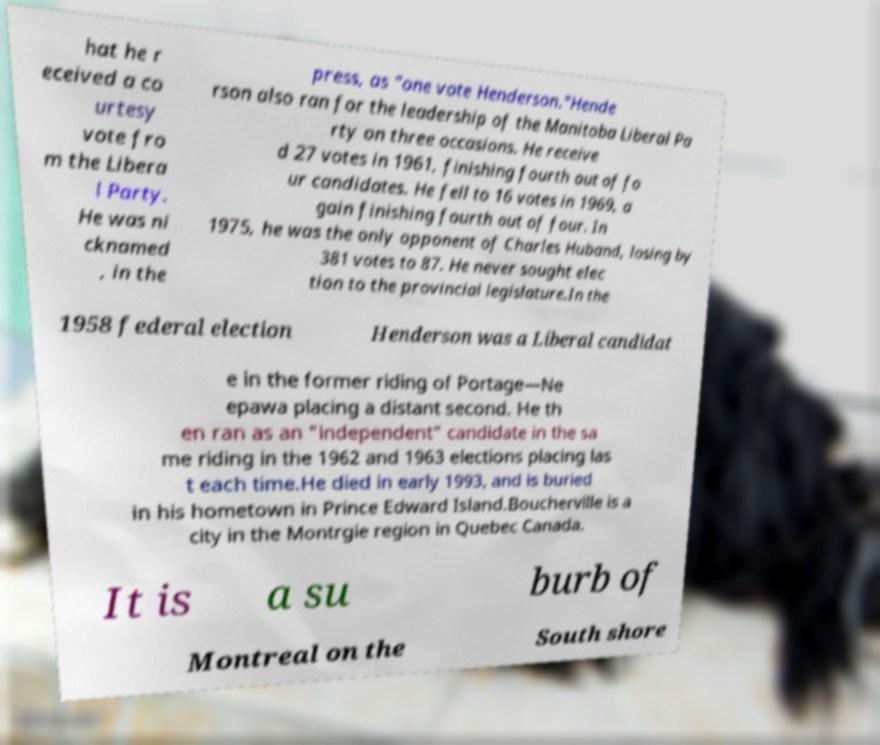What messages or text are displayed in this image? I need them in a readable, typed format. hat he r eceived a co urtesy vote fro m the Libera l Party. He was ni cknamed , in the press, as "one vote Henderson."Hende rson also ran for the leadership of the Manitoba Liberal Pa rty on three occasions. He receive d 27 votes in 1961, finishing fourth out of fo ur candidates. He fell to 16 votes in 1969, a gain finishing fourth out of four. In 1975, he was the only opponent of Charles Huband, losing by 381 votes to 87. He never sought elec tion to the provincial legislature.In the 1958 federal election Henderson was a Liberal candidat e in the former riding of Portage—Ne epawa placing a distant second. He th en ran as an "independent" candidate in the sa me riding in the 1962 and 1963 elections placing las t each time.He died in early 1993, and is buried in his hometown in Prince Edward Island.Boucherville is a city in the Montrgie region in Quebec Canada. It is a su burb of Montreal on the South shore 